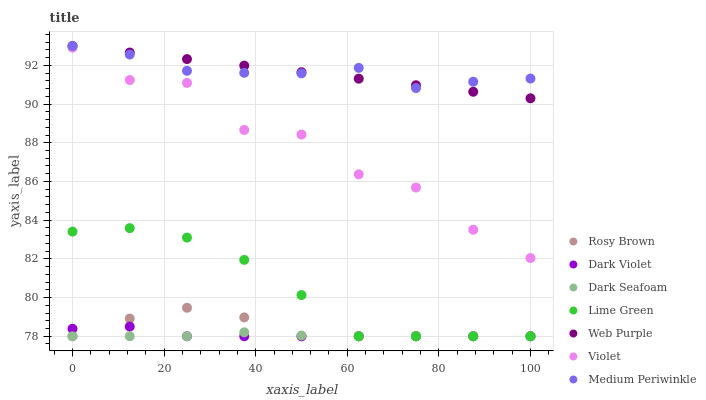Does Dark Seafoam have the minimum area under the curve?
Answer yes or no. Yes. Does Medium Periwinkle have the maximum area under the curve?
Answer yes or no. Yes. Does Web Purple have the minimum area under the curve?
Answer yes or no. No. Does Web Purple have the maximum area under the curve?
Answer yes or no. No. Is Web Purple the smoothest?
Answer yes or no. Yes. Is Violet the roughest?
Answer yes or no. Yes. Is Medium Periwinkle the smoothest?
Answer yes or no. No. Is Medium Periwinkle the roughest?
Answer yes or no. No. Does Rosy Brown have the lowest value?
Answer yes or no. Yes. Does Web Purple have the lowest value?
Answer yes or no. No. Does Web Purple have the highest value?
Answer yes or no. Yes. Does Dark Violet have the highest value?
Answer yes or no. No. Is Dark Seafoam less than Medium Periwinkle?
Answer yes or no. Yes. Is Medium Periwinkle greater than Dark Seafoam?
Answer yes or no. Yes. Does Web Purple intersect Medium Periwinkle?
Answer yes or no. Yes. Is Web Purple less than Medium Periwinkle?
Answer yes or no. No. Is Web Purple greater than Medium Periwinkle?
Answer yes or no. No. Does Dark Seafoam intersect Medium Periwinkle?
Answer yes or no. No. 